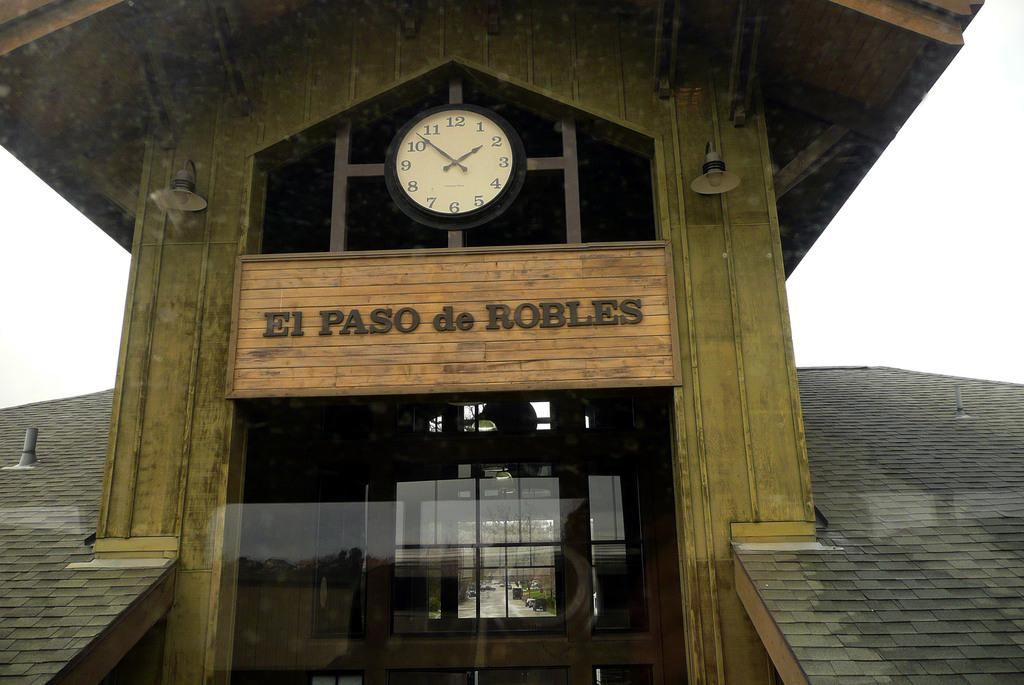<image>
Render a clear and concise summary of the photo. An old building that is titled EL PASO de ROBLES. 